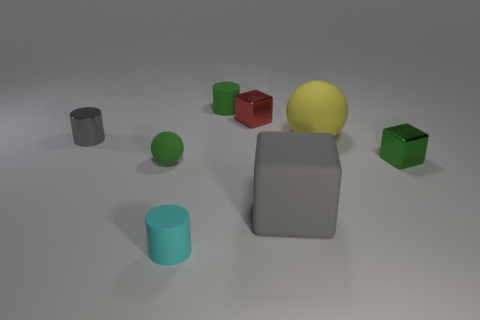Add 2 small blue spheres. How many objects exist? 10 Subtract all cubes. How many objects are left? 5 Add 5 large gray objects. How many large gray objects are left? 6 Add 3 tiny matte things. How many tiny matte things exist? 6 Subtract 1 green cylinders. How many objects are left? 7 Subtract all tiny metallic objects. Subtract all small green spheres. How many objects are left? 4 